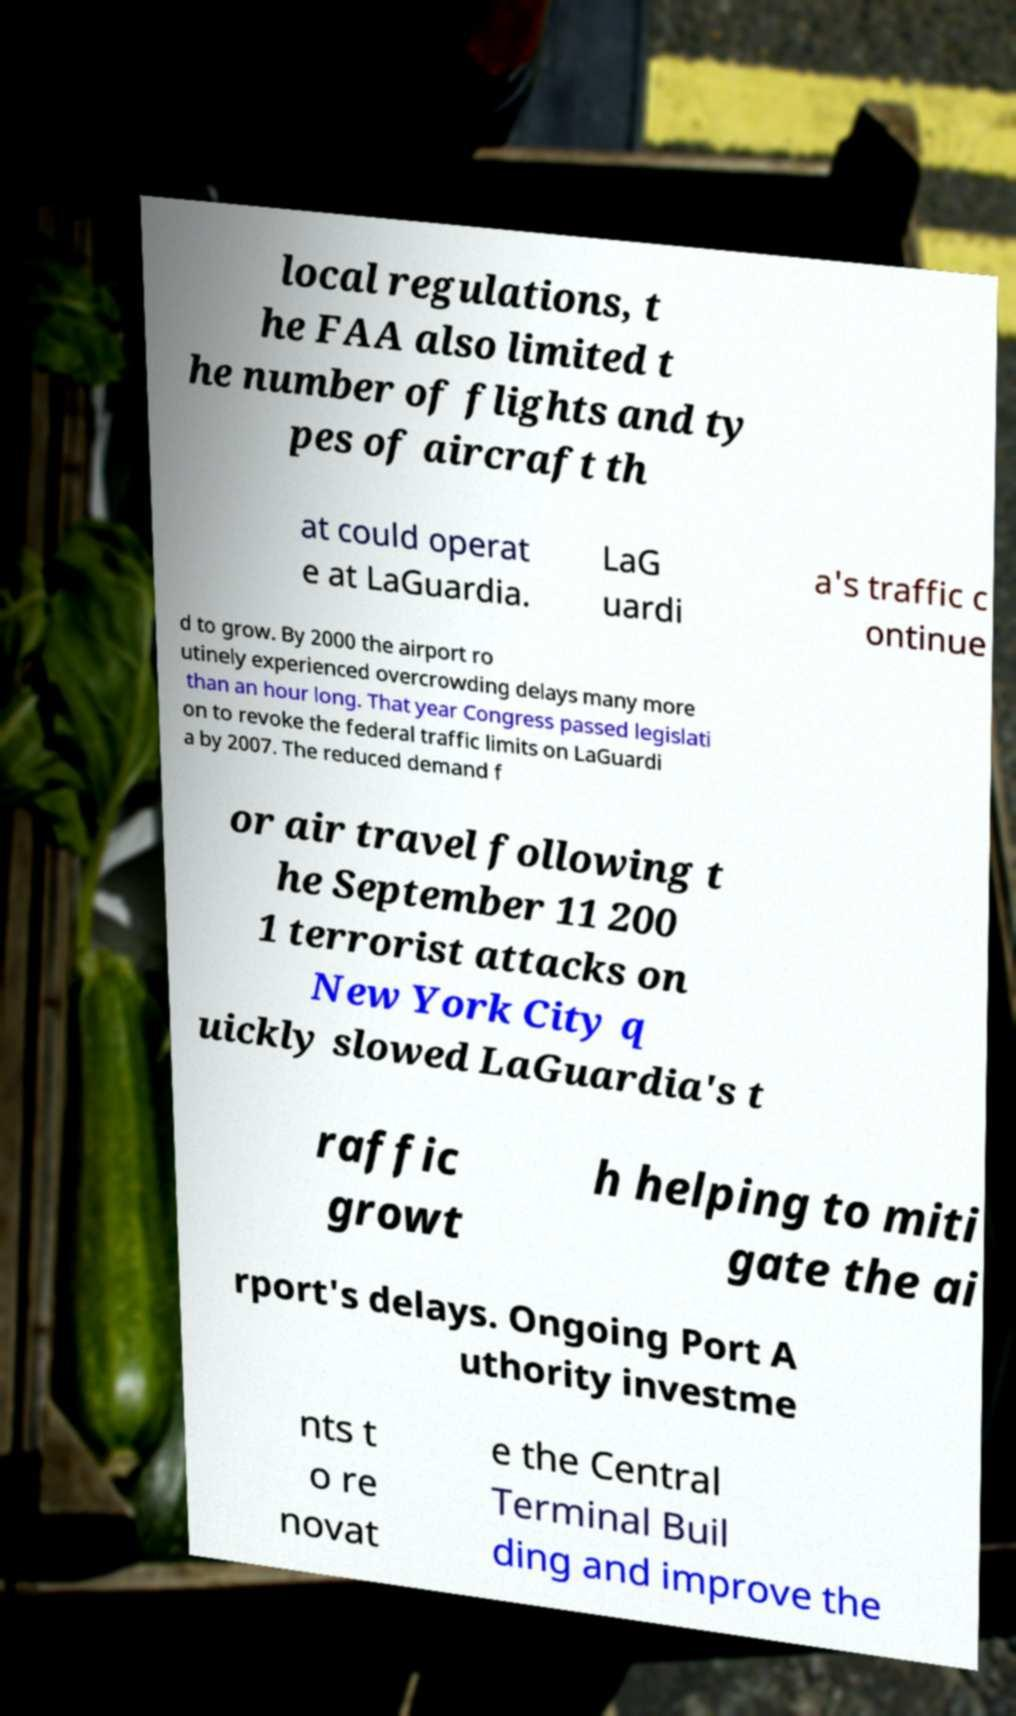Can you accurately transcribe the text from the provided image for me? local regulations, t he FAA also limited t he number of flights and ty pes of aircraft th at could operat e at LaGuardia. LaG uardi a's traffic c ontinue d to grow. By 2000 the airport ro utinely experienced overcrowding delays many more than an hour long. That year Congress passed legislati on to revoke the federal traffic limits on LaGuardi a by 2007. The reduced demand f or air travel following t he September 11 200 1 terrorist attacks on New York City q uickly slowed LaGuardia's t raffic growt h helping to miti gate the ai rport's delays. Ongoing Port A uthority investme nts t o re novat e the Central Terminal Buil ding and improve the 